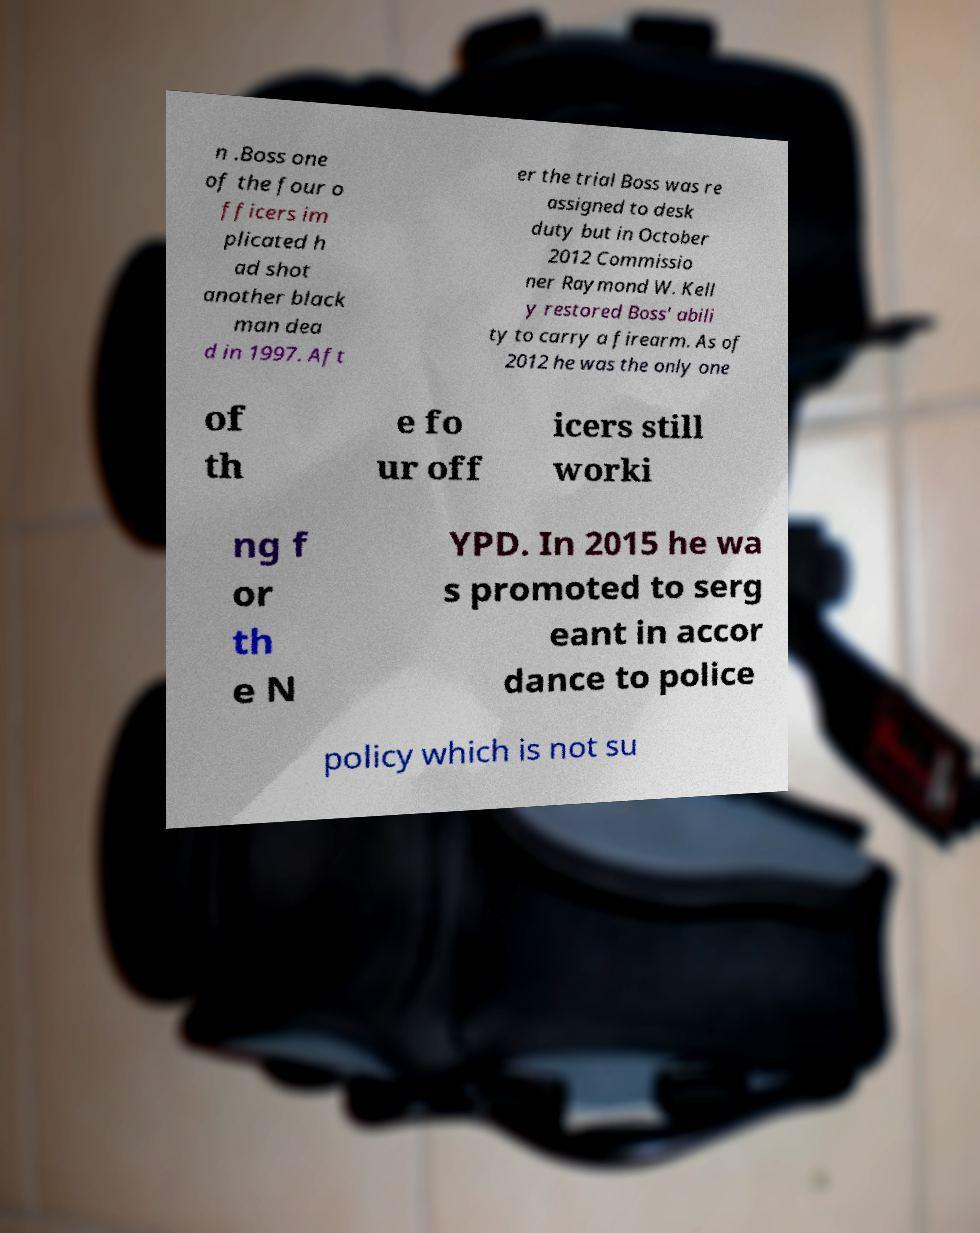Please identify and transcribe the text found in this image. n .Boss one of the four o fficers im plicated h ad shot another black man dea d in 1997. Aft er the trial Boss was re assigned to desk duty but in October 2012 Commissio ner Raymond W. Kell y restored Boss' abili ty to carry a firearm. As of 2012 he was the only one of th e fo ur off icers still worki ng f or th e N YPD. In 2015 he wa s promoted to serg eant in accor dance to police policy which is not su 